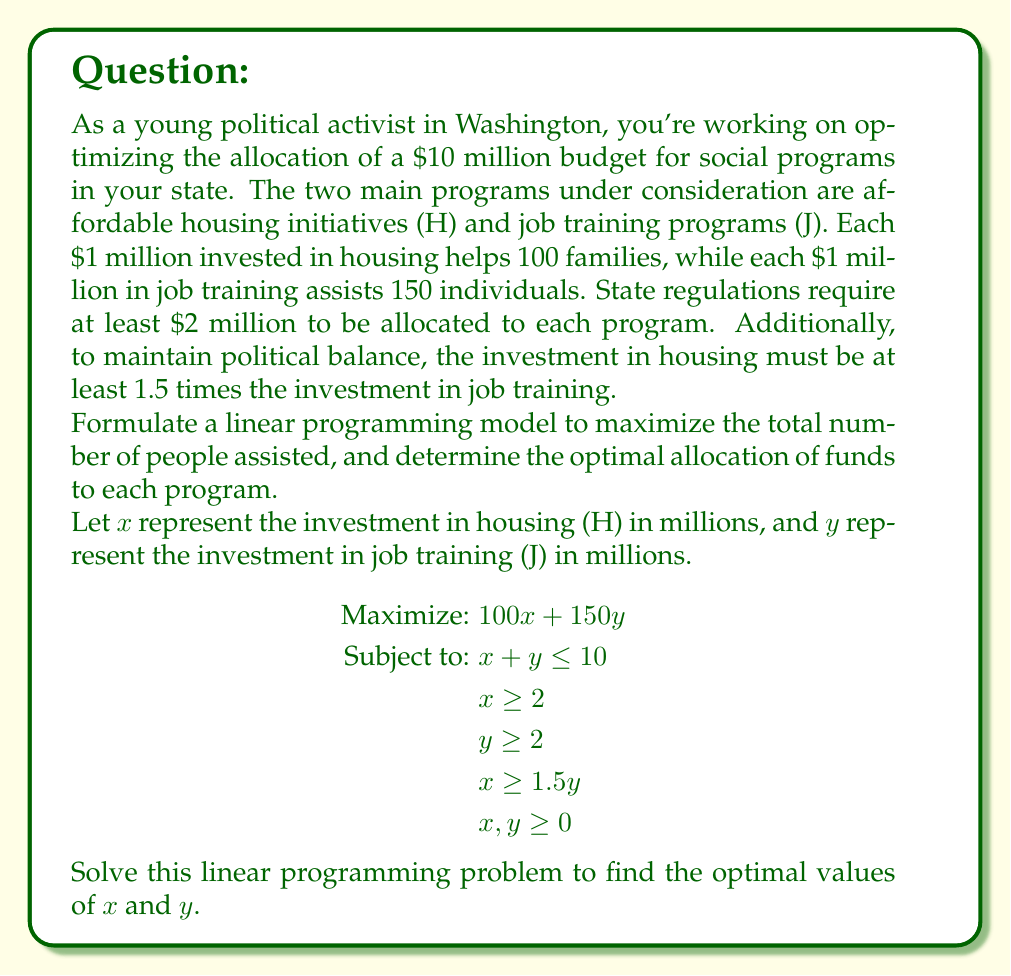Help me with this question. To solve this linear programming problem, we'll use the graphical method:

1) First, plot the constraints:
   - $x + y = 10$ (budget constraint)
   - $x = 2$ and $y = 2$ (minimum allocations)
   - $x = 1.5y$ (political balance constraint)

2) Identify the feasible region, which is the area that satisfies all constraints.

3) The vertices of the feasible region are the potential optimal solutions. They are:
   (6, 4), (7.5, 2.5), and (8, 2)

4) Evaluate the objective function $Z = 100x + 150y$ at each vertex:
   - At (6, 4): $Z = 100(6) + 150(4) = 1200$
   - At (7.5, 2.5): $Z = 100(7.5) + 150(2.5) = 1125$
   - At (8, 2): $Z = 100(8) + 150(2) = 1100$

5) The maximum value occurs at the point (6, 4).

Therefore, the optimal solution is to invest $6 million in housing initiatives and $4 million in job training programs.

This allocation will assist:
- Housing: $100 * 6 = 600$ families
- Job Training: $150 * 4 = 600$ individuals

Total people assisted: $600 + 600 = 1200$
Answer: Optimal allocation: $6 million for housing, $4 million for job training. Total assisted: 1200 people. 